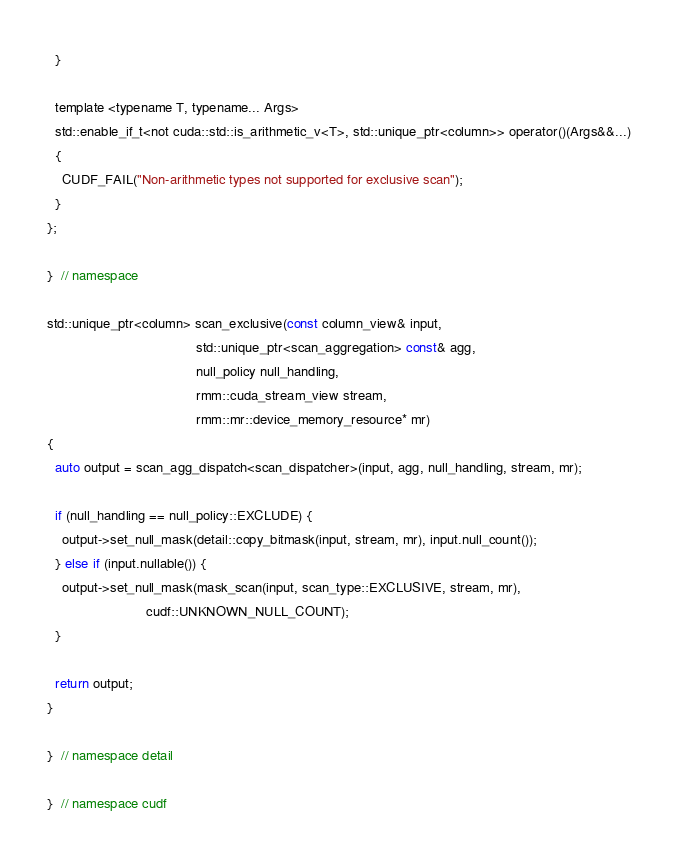Convert code to text. <code><loc_0><loc_0><loc_500><loc_500><_Cuda_>  }

  template <typename T, typename... Args>
  std::enable_if_t<not cuda::std::is_arithmetic_v<T>, std::unique_ptr<column>> operator()(Args&&...)
  {
    CUDF_FAIL("Non-arithmetic types not supported for exclusive scan");
  }
};

}  // namespace

std::unique_ptr<column> scan_exclusive(const column_view& input,
                                       std::unique_ptr<scan_aggregation> const& agg,
                                       null_policy null_handling,
                                       rmm::cuda_stream_view stream,
                                       rmm::mr::device_memory_resource* mr)
{
  auto output = scan_agg_dispatch<scan_dispatcher>(input, agg, null_handling, stream, mr);

  if (null_handling == null_policy::EXCLUDE) {
    output->set_null_mask(detail::copy_bitmask(input, stream, mr), input.null_count());
  } else if (input.nullable()) {
    output->set_null_mask(mask_scan(input, scan_type::EXCLUSIVE, stream, mr),
                          cudf::UNKNOWN_NULL_COUNT);
  }

  return output;
}

}  // namespace detail

}  // namespace cudf
</code> 